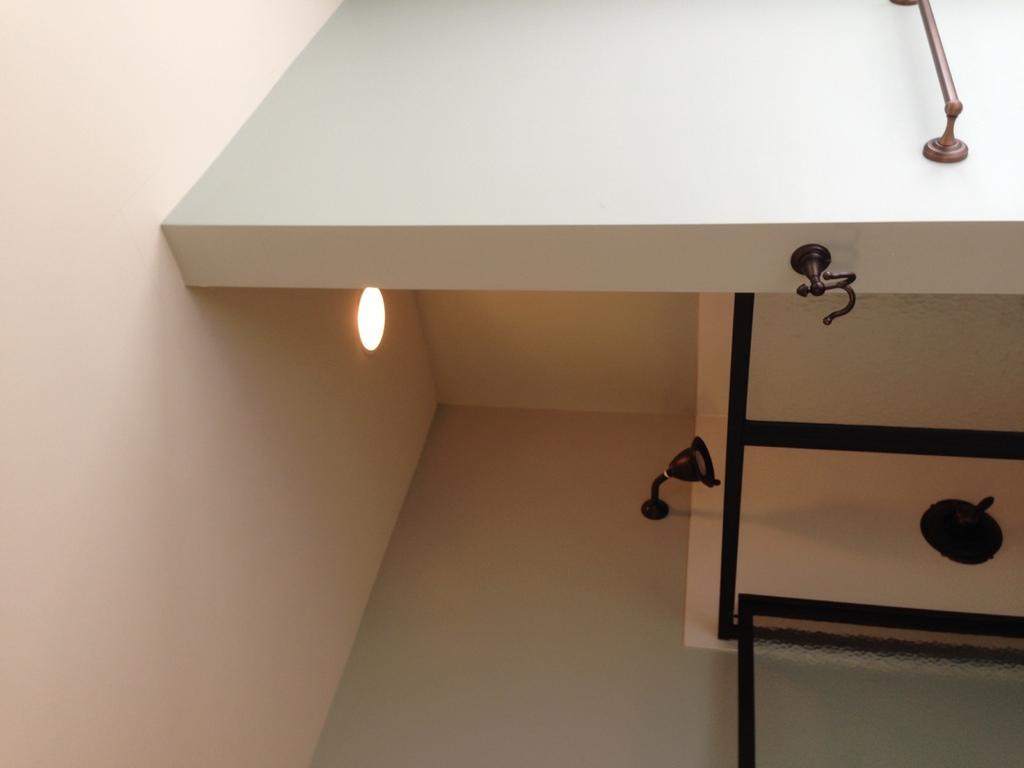In one or two sentences, can you explain what this image depicts? In this image, we can see walls. On the right side of the image, we can see glass objects, holder, rod and some object. 